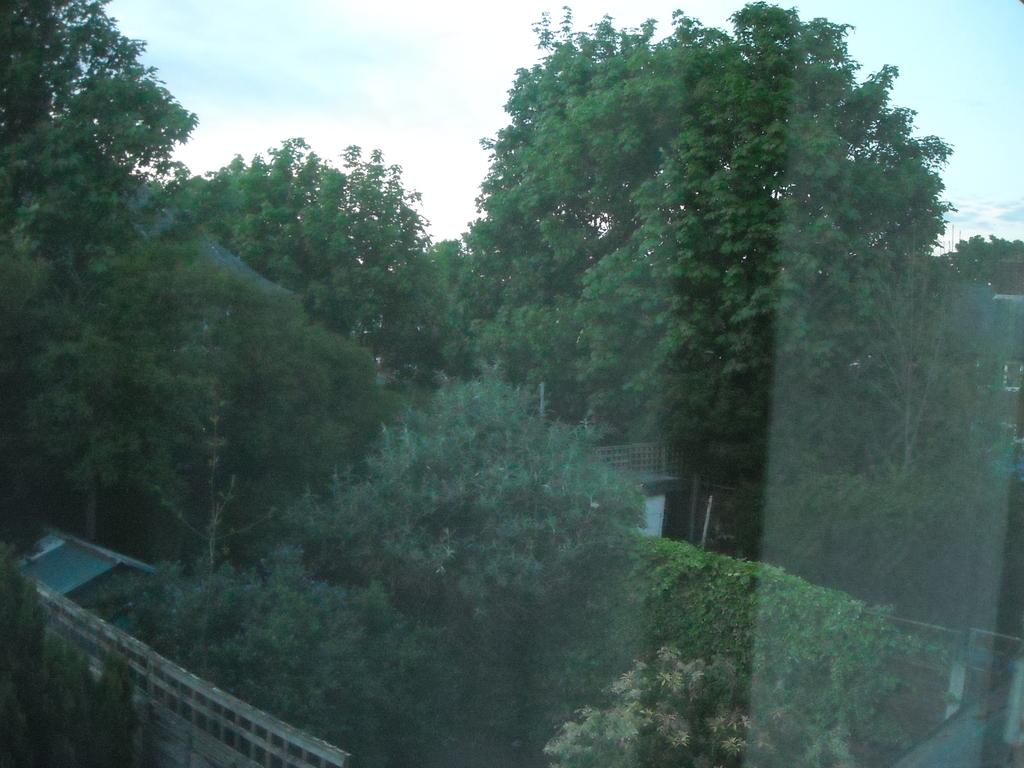What is the vantage point of the image? The image is taken from the outside of a glass window. What type of natural elements can be seen in the image? There are trees and plants in the image. What type of structure is visible in the image? There is a house in the image. What architectural feature is present in the image? There is a wall in the image. What is visible at the top of the image? The sky is visible at the top of the image. What is the weather like in the image? The sky is cloudy in the image. What type of agreement is being signed in the image? There is no agreement or signing activity present in the image. What type of motion can be observed in the image? There is no motion or movement visible in the image; it is a still photograph. 